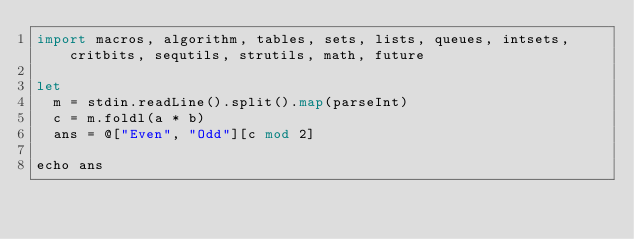<code> <loc_0><loc_0><loc_500><loc_500><_Nim_>import macros, algorithm, tables, sets, lists, queues, intsets, critbits, sequtils, strutils, math, future

let
  m = stdin.readLine().split().map(parseInt)
  c = m.foldl(a * b)
  ans = @["Even", "Odd"][c mod 2]

echo ans</code> 